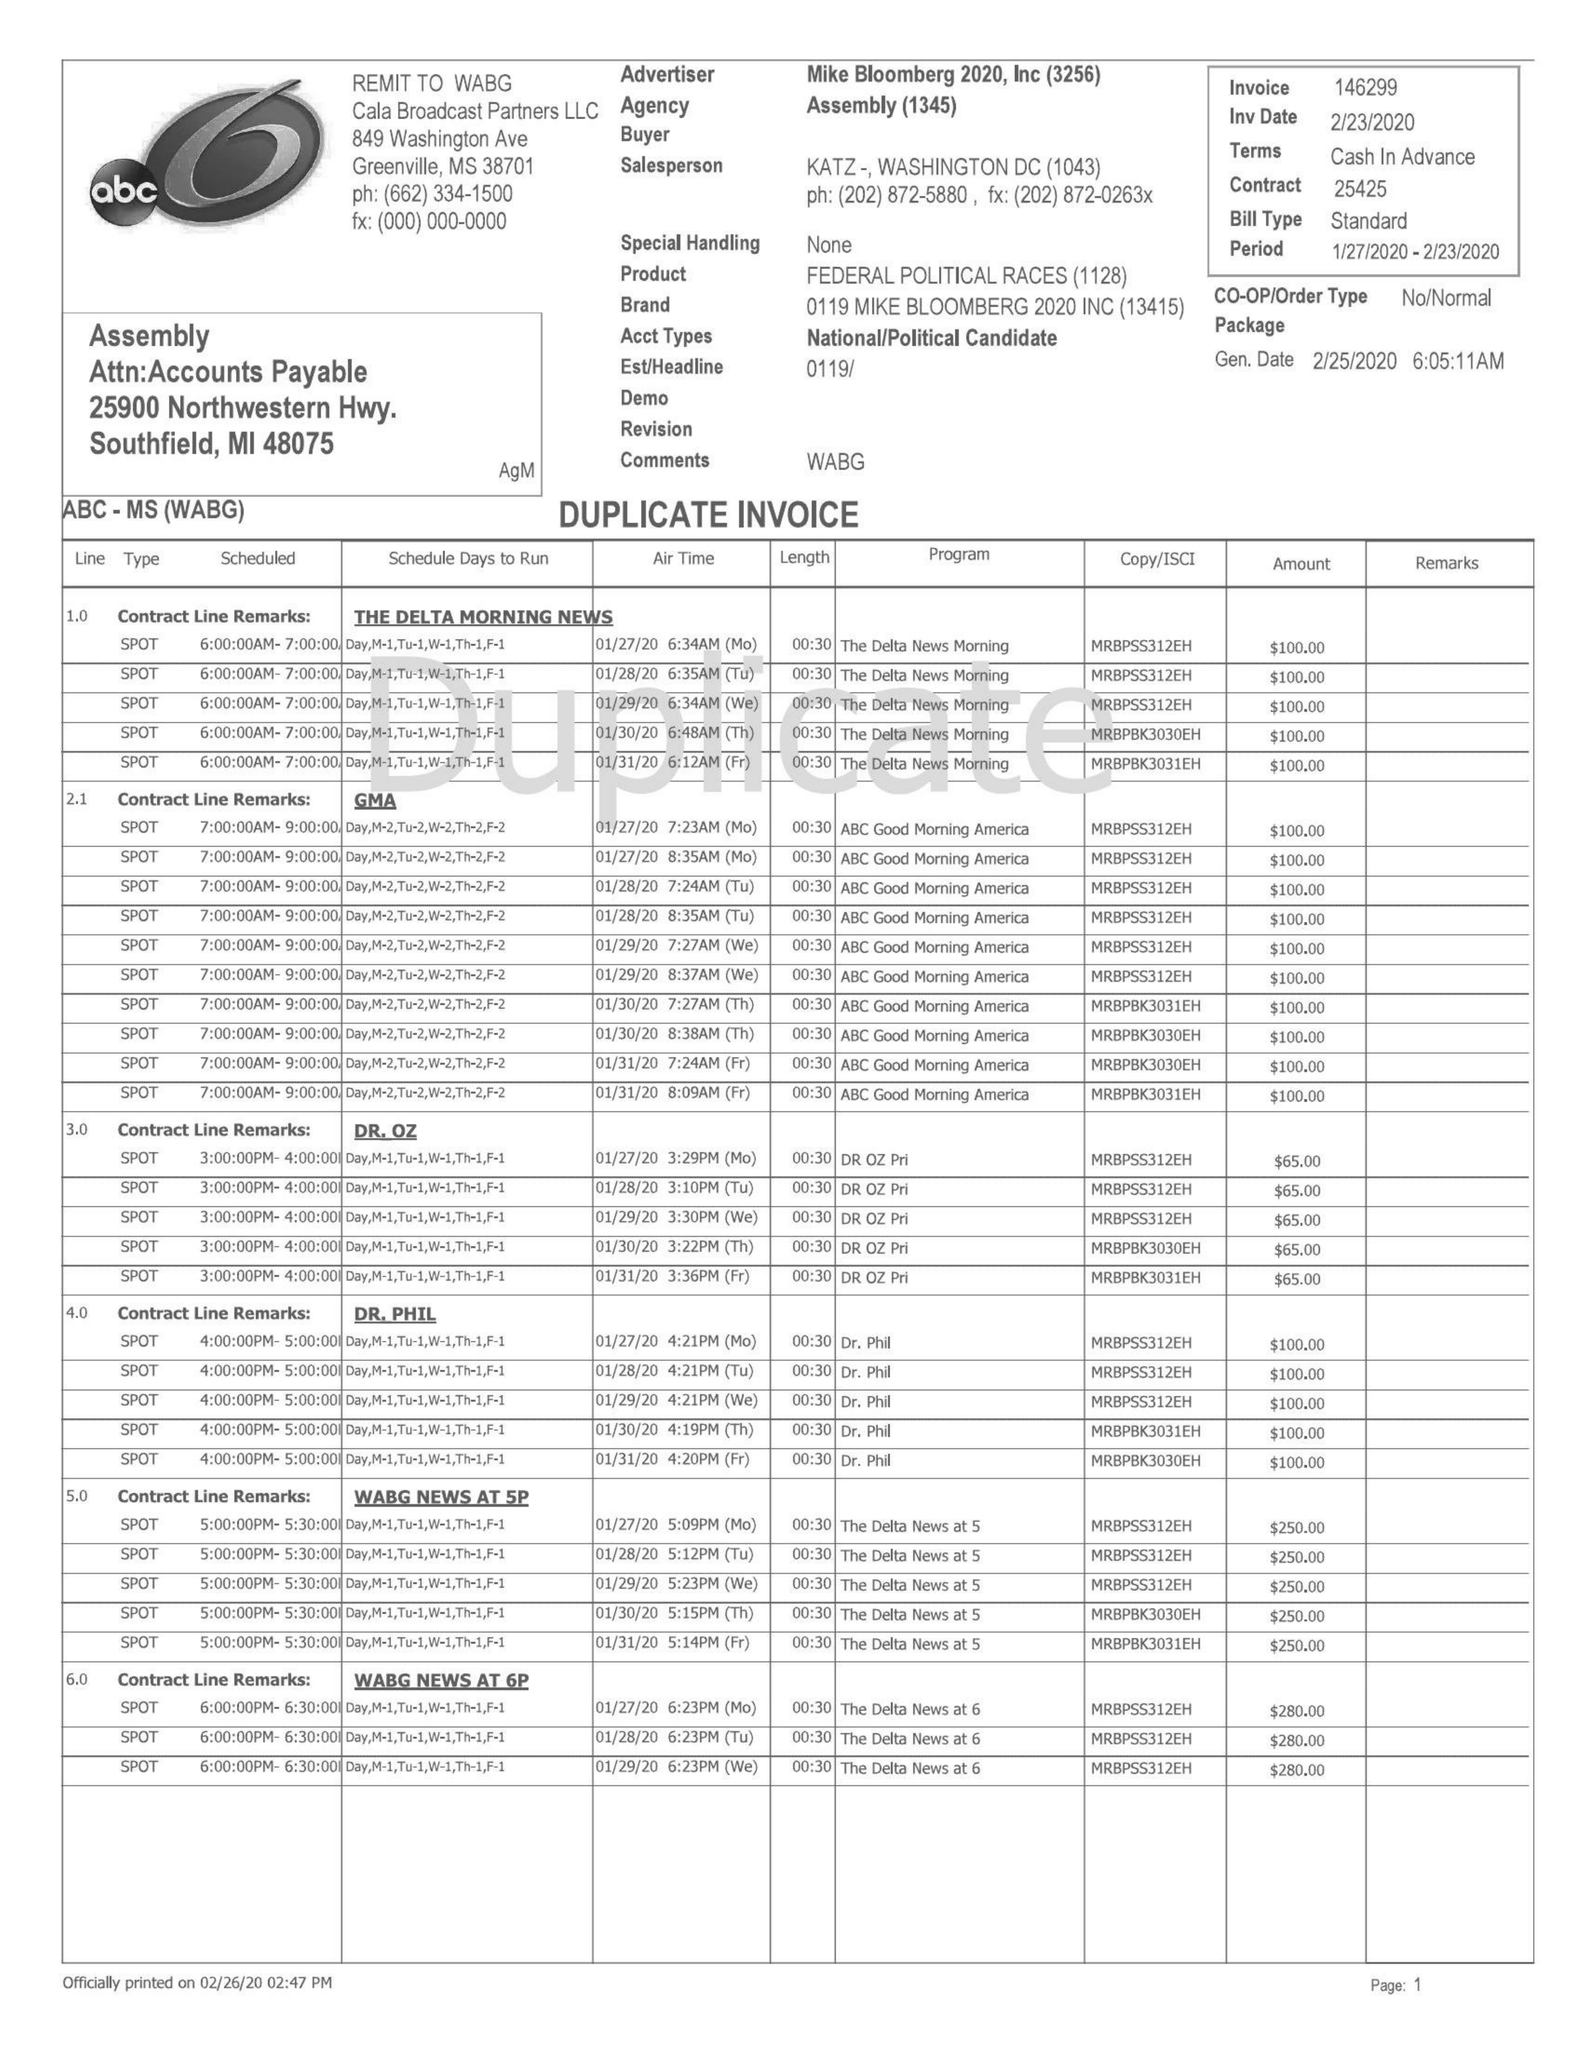What is the value for the flight_to?
Answer the question using a single word or phrase. 02/23/20 